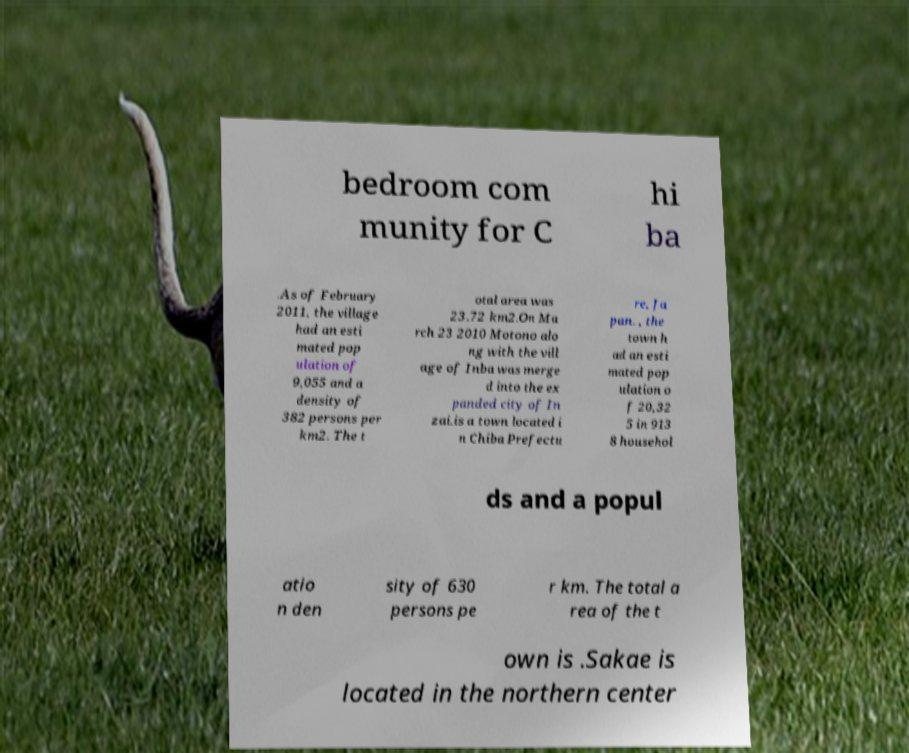Could you extract and type out the text from this image? bedroom com munity for C hi ba .As of February 2011, the village had an esti mated pop ulation of 9,055 and a density of 382 persons per km2. The t otal area was 23.72 km2.On Ma rch 23 2010 Motono alo ng with the vill age of Inba was merge d into the ex panded city of In zai.is a town located i n Chiba Prefectu re, Ja pan. , the town h ad an esti mated pop ulation o f 20,32 5 in 913 8 househol ds and a popul atio n den sity of 630 persons pe r km. The total a rea of the t own is .Sakae is located in the northern center 